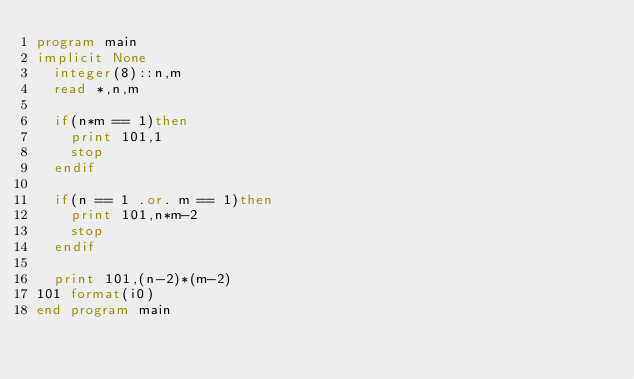<code> <loc_0><loc_0><loc_500><loc_500><_FORTRAN_>program main
implicit None
	integer(8)::n,m
	read *,n,m
	
	if(n*m == 1)then
		print 101,1
		stop
	endif
	
	if(n == 1 .or. m == 1)then
		print 101,n*m-2
		stop
	endif
	
	print 101,(n-2)*(m-2)
101 format(i0)
end program main</code> 